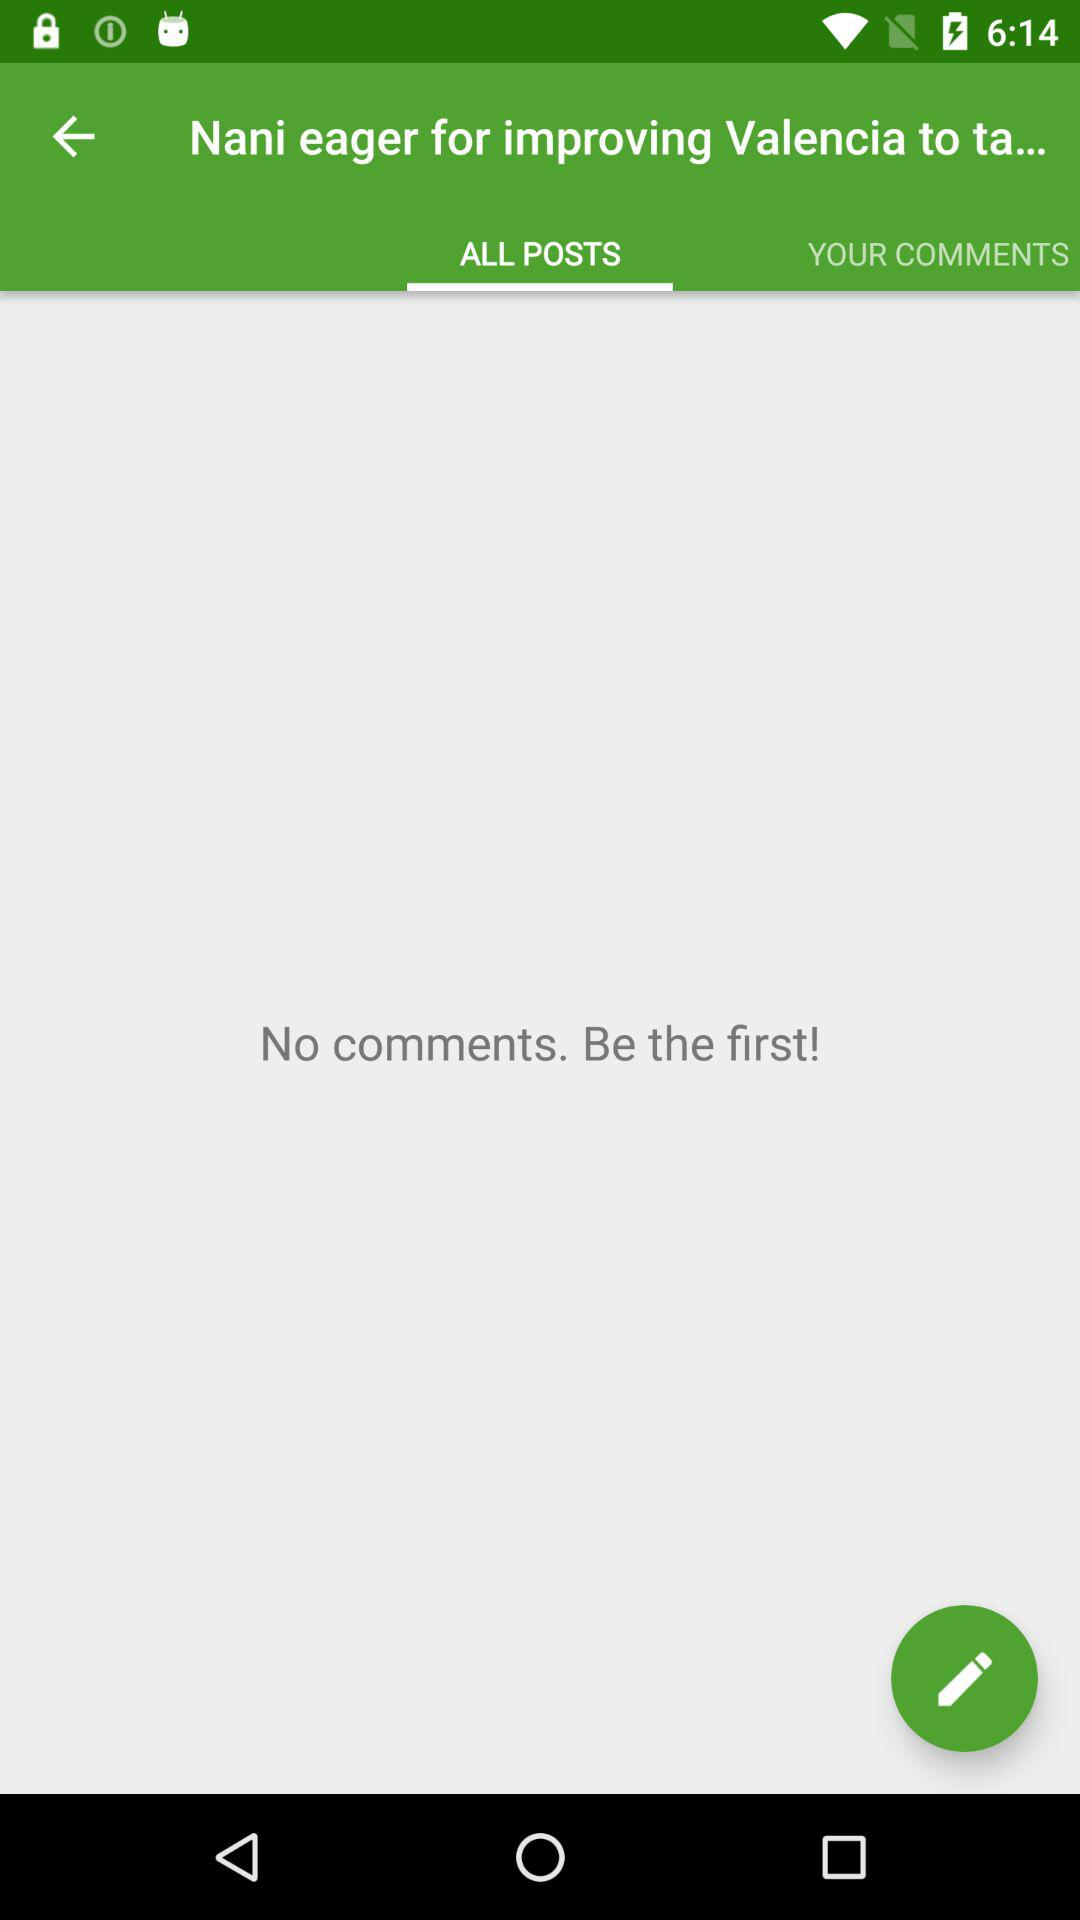Which tab is selected? The selected tab is "ALL POSTS". 